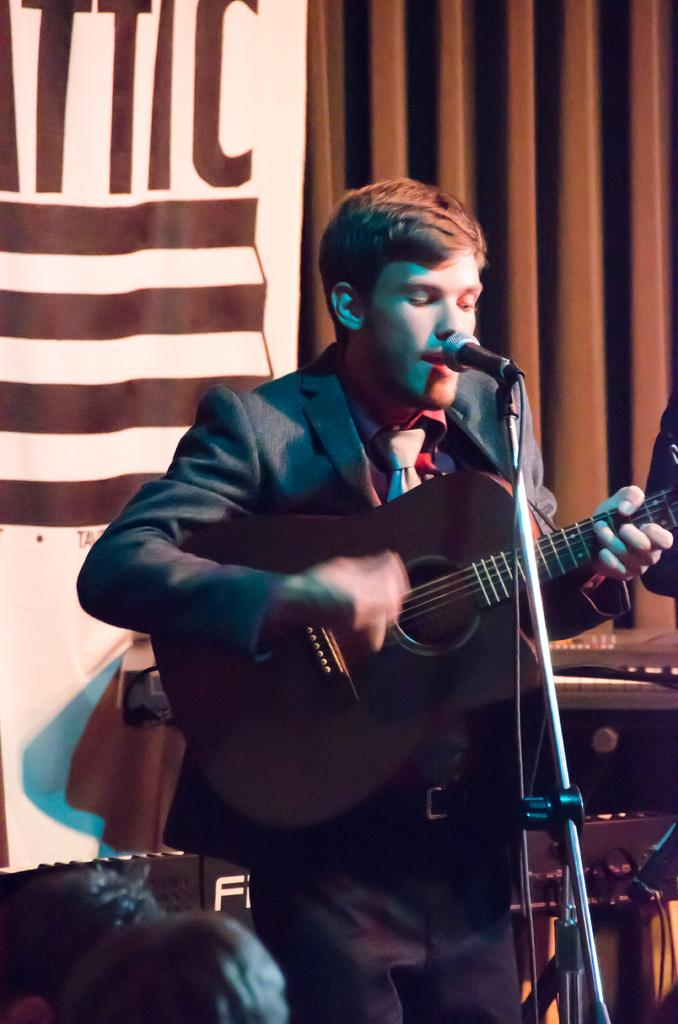What is the man in the image holding? The man is holding a guitar. What object is in front of the man? There is a microphone in front of the man. Can you see a ship in the image? No, there is no ship present in the image. What type of fruit is the man holding in the image? The man is not holding any fruit in the image; he is holding a guitar. 